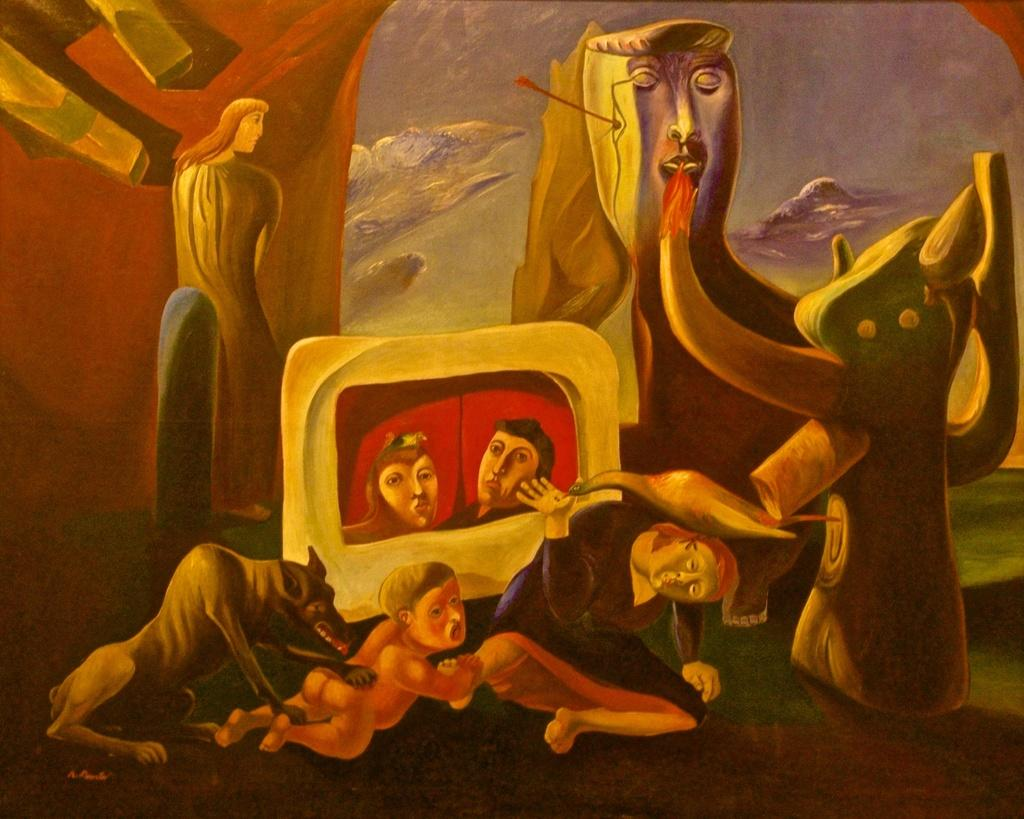What style is the image drawn in? The image is a cartoon picture. What form of teaching is being demonstrated in the image? There is no teaching activity depicted in the image, as it is a cartoon picture and not a scene from a classroom or educational setting. 